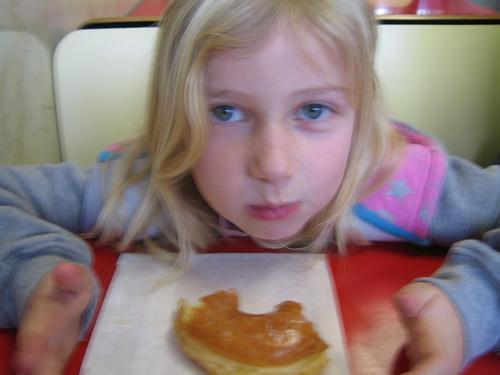How many donuts are visible?
Give a very brief answer. 1. How many dogs have a frisbee in their mouth?
Give a very brief answer. 0. 